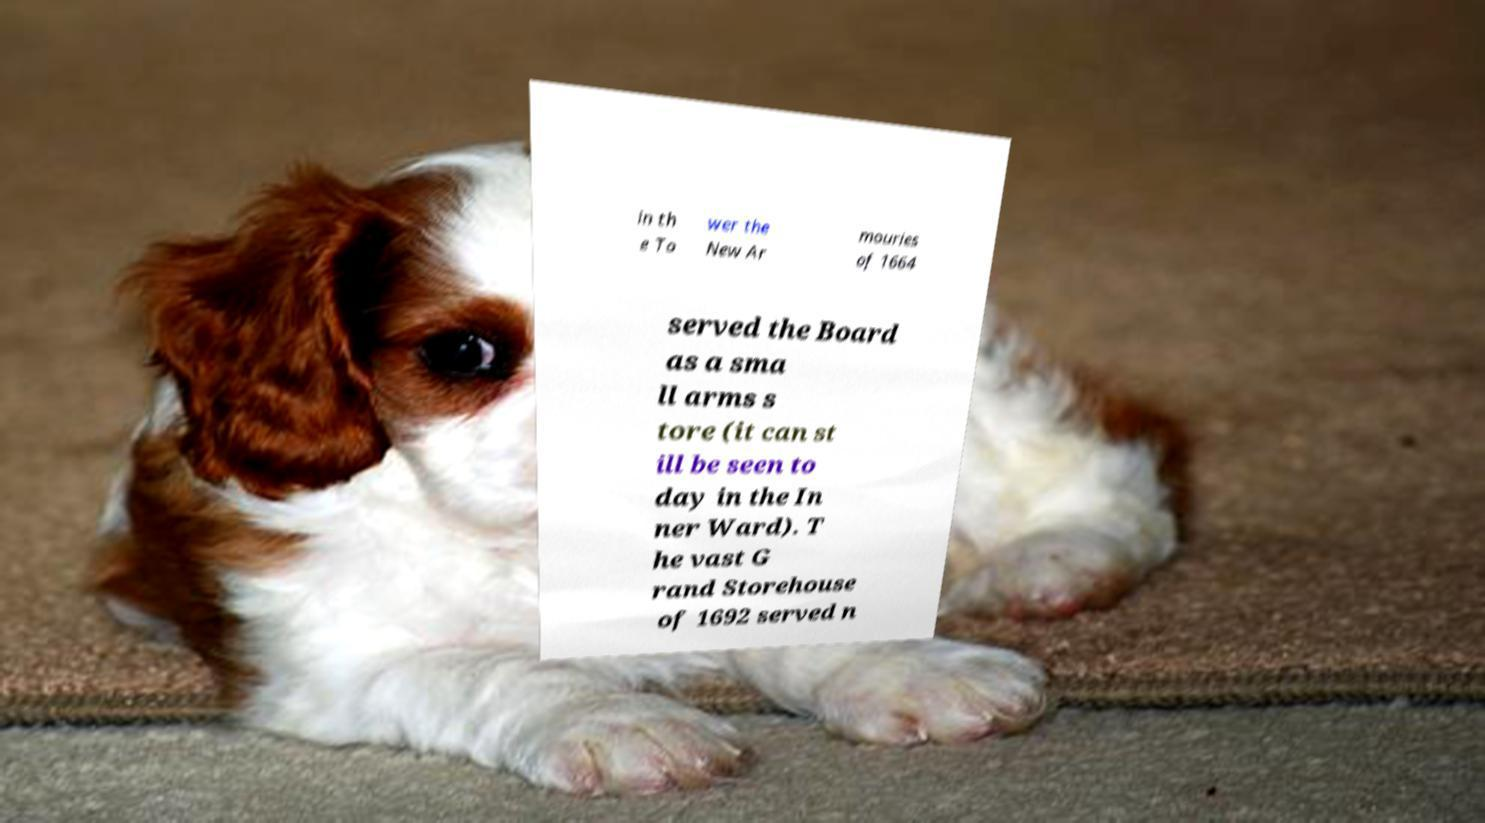Please identify and transcribe the text found in this image. in th e To wer the New Ar mouries of 1664 served the Board as a sma ll arms s tore (it can st ill be seen to day in the In ner Ward). T he vast G rand Storehouse of 1692 served n 